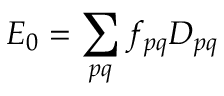<formula> <loc_0><loc_0><loc_500><loc_500>E _ { 0 } = \sum _ { p q } f _ { p q } D _ { p q }</formula> 